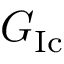Convert formula to latex. <formula><loc_0><loc_0><loc_500><loc_500>G _ { I c }</formula> 